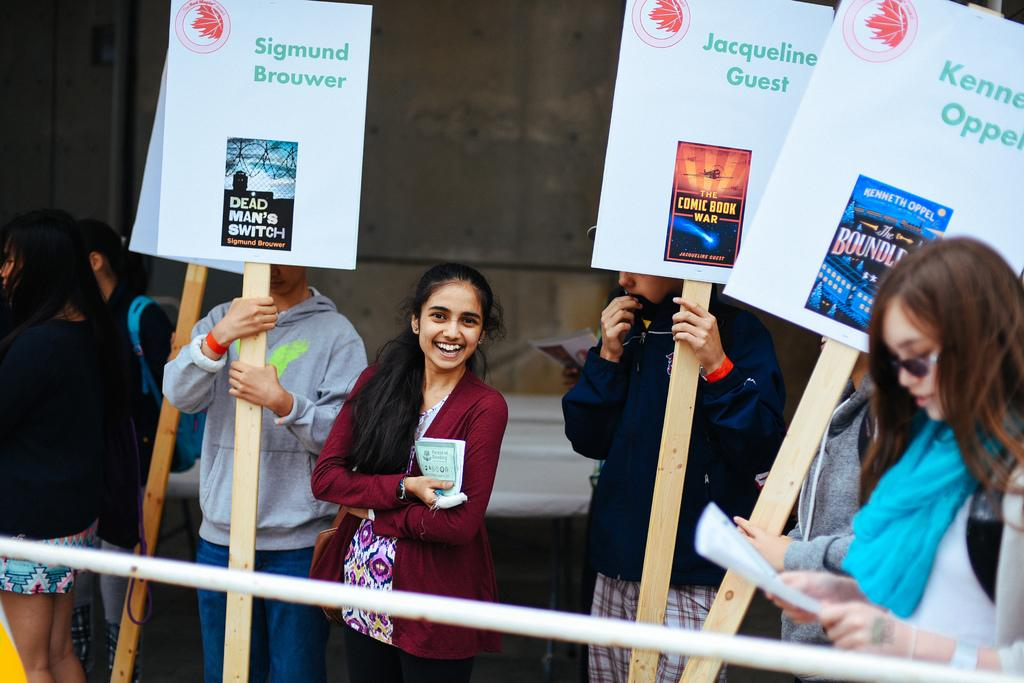How many people are present in the image? There are people in the image, but the exact number is not specified. What are two of the people holding in the image? Two of the people are holding papers, and two are holding boards. What can be seen in the background of the image? There is a wall in the background of the image. What type of bean is being used to calculate the profit in the image? There is no mention of beans or profit in the image, so this question cannot be answered. 